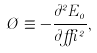Convert formula to latex. <formula><loc_0><loc_0><loc_500><loc_500>\chi \equiv - \frac { \partial ^ { 2 } E _ { 0 } } { \partial \delta ^ { 2 } } ,</formula> 